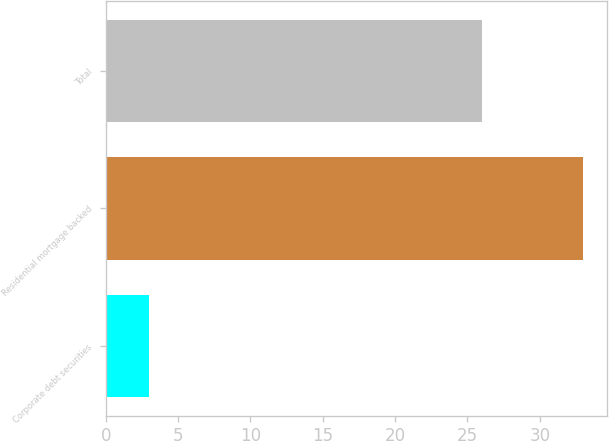<chart> <loc_0><loc_0><loc_500><loc_500><bar_chart><fcel>Corporate debt securities<fcel>Residential mortgage backed<fcel>Total<nl><fcel>3<fcel>33<fcel>26<nl></chart> 